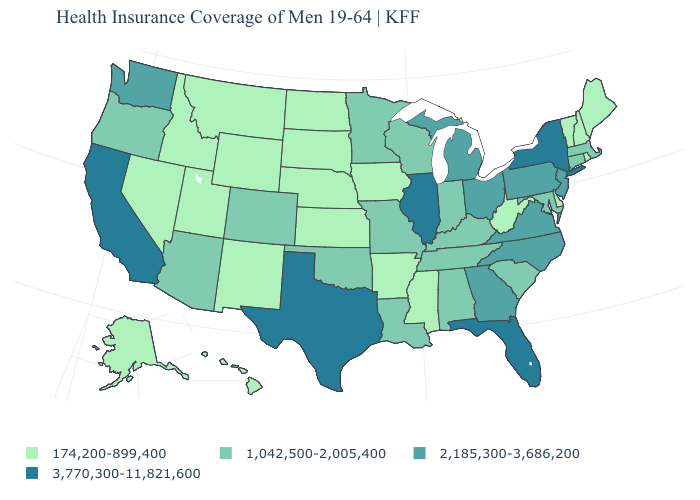Which states have the highest value in the USA?
Keep it brief. California, Florida, Illinois, New York, Texas. What is the lowest value in the MidWest?
Be succinct. 174,200-899,400. Name the states that have a value in the range 3,770,300-11,821,600?
Be succinct. California, Florida, Illinois, New York, Texas. What is the value of Colorado?
Keep it brief. 1,042,500-2,005,400. What is the value of Montana?
Short answer required. 174,200-899,400. What is the value of Arizona?
Keep it brief. 1,042,500-2,005,400. Which states hav the highest value in the West?
Keep it brief. California. Name the states that have a value in the range 2,185,300-3,686,200?
Keep it brief. Georgia, Michigan, New Jersey, North Carolina, Ohio, Pennsylvania, Virginia, Washington. Does North Dakota have a lower value than Kansas?
Answer briefly. No. Name the states that have a value in the range 1,042,500-2,005,400?
Give a very brief answer. Alabama, Arizona, Colorado, Connecticut, Indiana, Kentucky, Louisiana, Maryland, Massachusetts, Minnesota, Missouri, Oklahoma, Oregon, South Carolina, Tennessee, Wisconsin. Name the states that have a value in the range 174,200-899,400?
Concise answer only. Alaska, Arkansas, Delaware, Hawaii, Idaho, Iowa, Kansas, Maine, Mississippi, Montana, Nebraska, Nevada, New Hampshire, New Mexico, North Dakota, Rhode Island, South Dakota, Utah, Vermont, West Virginia, Wyoming. Name the states that have a value in the range 3,770,300-11,821,600?
Quick response, please. California, Florida, Illinois, New York, Texas. What is the highest value in states that border Michigan?
Quick response, please. 2,185,300-3,686,200. Does Missouri have the same value as Arkansas?
Quick response, please. No. What is the highest value in the MidWest ?
Concise answer only. 3,770,300-11,821,600. 